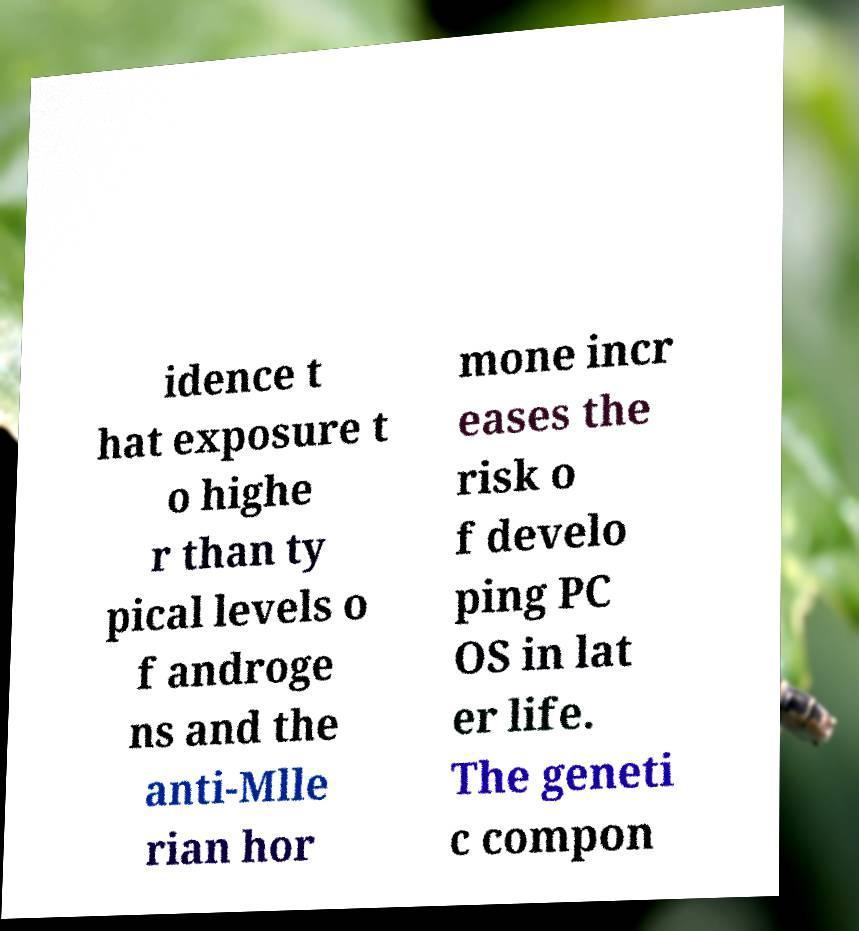What messages or text are displayed in this image? I need them in a readable, typed format. idence t hat exposure t o highe r than ty pical levels o f androge ns and the anti-Mlle rian hor mone incr eases the risk o f develo ping PC OS in lat er life. The geneti c compon 